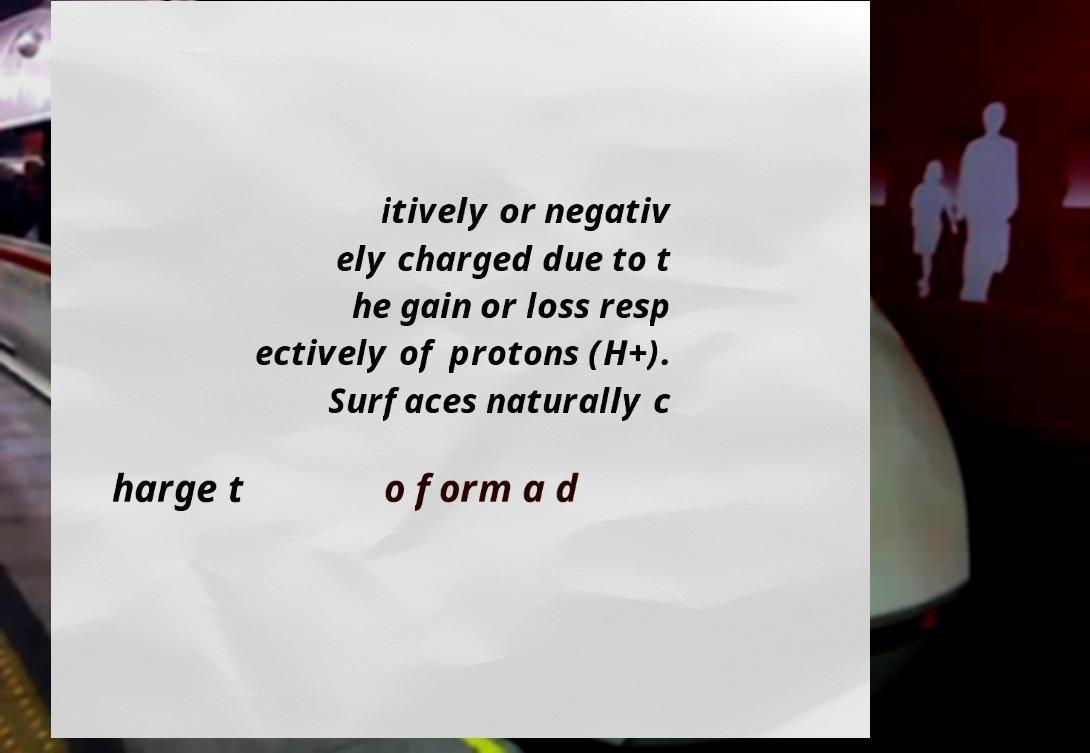Could you assist in decoding the text presented in this image and type it out clearly? itively or negativ ely charged due to t he gain or loss resp ectively of protons (H+). Surfaces naturally c harge t o form a d 